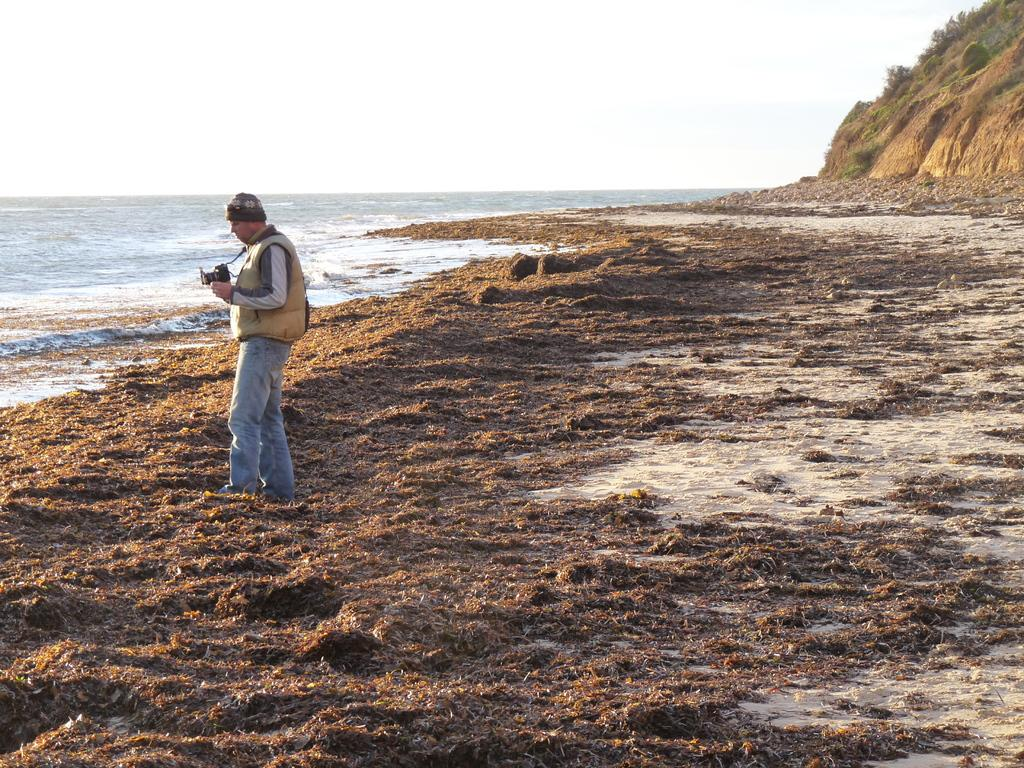Who is present in the image? There is a person in the image. What is the person holding? The person is holding a camera. Where is the person standing? The person is standing in front of the ocean. What other geographical feature can be seen in the image? There is a hill visible in the top right of the image. What is visible at the top of the image? The sky is visible at the top of the image. What type of fruit is being used as a prop in the image? There is no fruit present in the image. Is the person playing baseball in the image? There is no indication of a baseball game or any baseball-related activity in the image. 